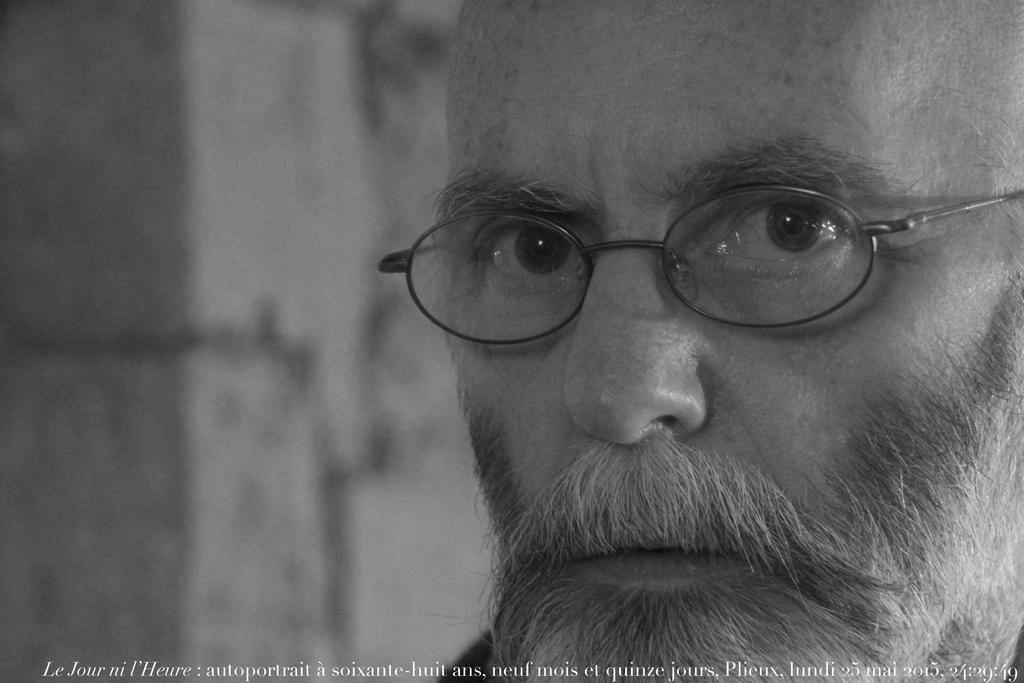Please provide a concise description of this image. In this picture we can see a person wearing a spectacle. We can see some text and numbers at the bottom of the picture. Background is blurry. 